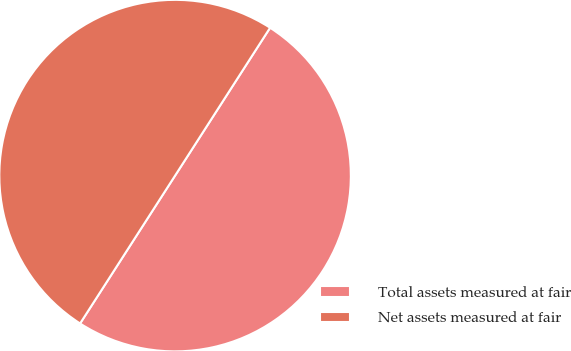Convert chart to OTSL. <chart><loc_0><loc_0><loc_500><loc_500><pie_chart><fcel>Total assets measured at fair<fcel>Net assets measured at fair<nl><fcel>50.0%<fcel>50.0%<nl></chart> 